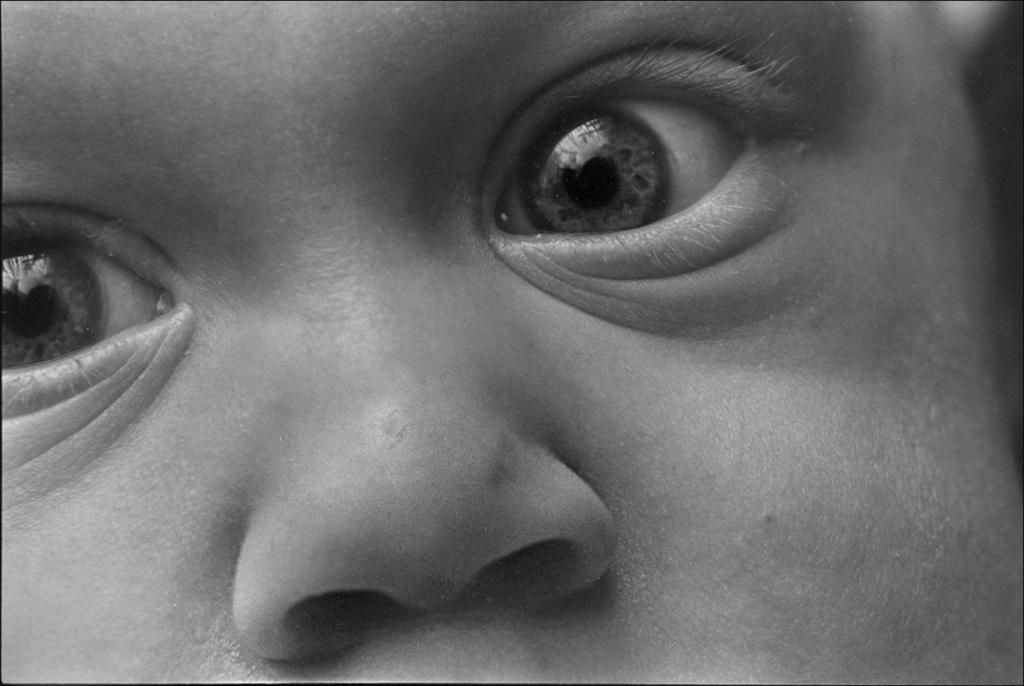Please provide a concise description of this image. In this image we can see the face of a human included with eyes and nose. 